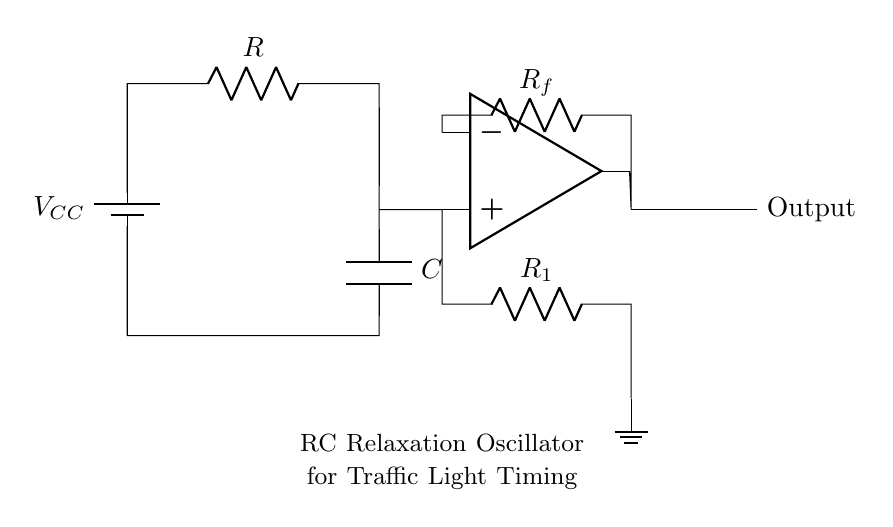What is the function of the capacitor in this circuit? The capacitor in this RC relaxation oscillator stores electrical energy and discharges it, creating the timing cycle that determines the oscillation frequency.
Answer: Stores energy What component determines the timing interval for the oscillator? The timing interval is primarily determined by the values of the resistor and the capacitor in the circuit, together referred to as the RC time constant.
Answer: Resistor and capacitor How many resistors are in the circuit? There are two resistors in the circuit, one connected to the capacitor and one that is used as a feedback resistor for the op-amp.
Answer: Two What is the role of the op-amp in this oscillator circuit? The op-amp acts as a voltage comparator, switching the output state as the capacitor charges and discharges, allowing for the generation of oscillations.
Answer: Voltage comparator What type of circuit is represented here? This circuit is an RC relaxation oscillator, utilized for generating periodic signals in timing applications, such as traffic light control.
Answer: RC relaxation oscillator 